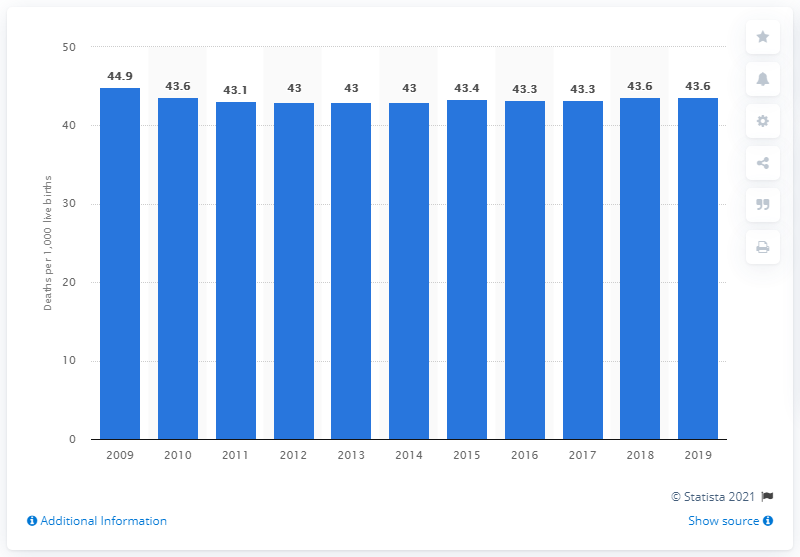Mention a couple of crucial points in this snapshot. In 2019, the infant mortality rate in Yemen was 43.6 deaths per 1,000 live births. 